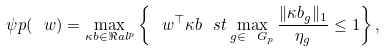Convert formula to latex. <formula><loc_0><loc_0><loc_500><loc_500>\psi p ( \ w ) = \max _ { \kappa b \in \Re a l ^ { p } } \left \{ \ w ^ { \top } \kappa b \ s t \max _ { g \in \ G _ { p } } \frac { \| \kappa b _ { g } \| _ { 1 } } { \eta _ { g } } \leq 1 \right \} ,</formula> 